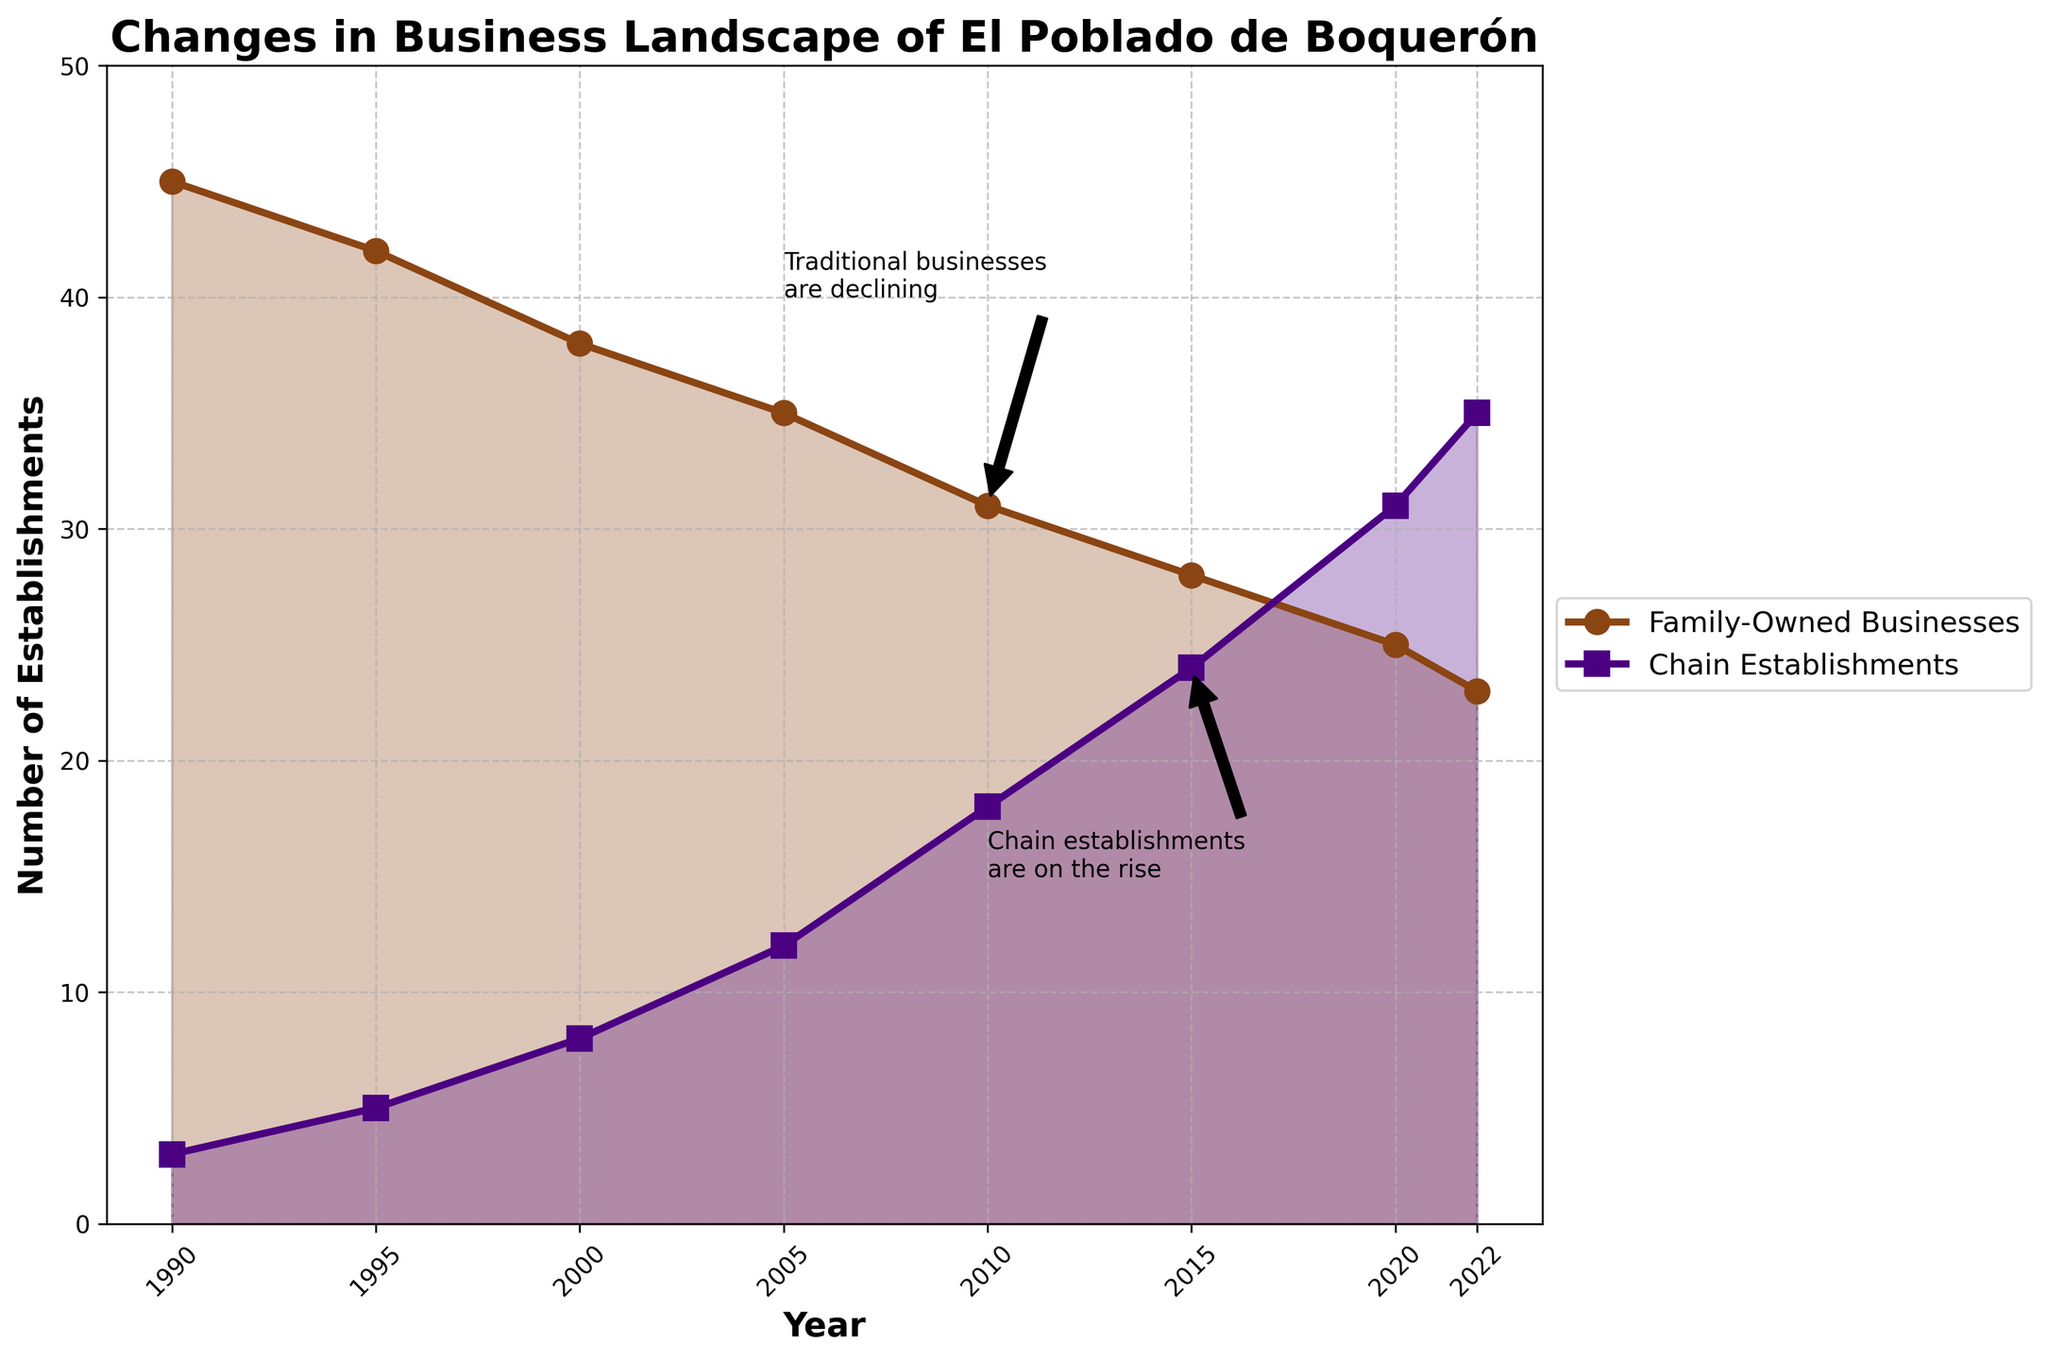What is the overall trend for family-owned businesses from 1990 to 2022? The number of family-owned businesses consistently decreases from 45 in 1990 to 23 in 2022.
Answer: Decreasing trend How many more chain establishments are there in 2022 compared to 1990? In 1990, there were 3 chain establishments, whereas in 2022 there are 35. The difference is 35 - 3.
Answer: 32 Which year had the highest increase in chain establishments compared to the previous period? Compare the increases for each period:
1990-1995: 5 - 3 = 2
1995-2000: 8 - 5 = 3
2000-2005: 12 - 8 = 4
2005-2010: 18 - 12 = 6
2010-2015: 24 - 18 = 6
2015-2020: 31 - 24 = 7
2020-2022: 35 - 31 = 4
The highest increase is in 2015-2020 with an increase of 7.
Answer: 2015-2020 What was the number of family-owned businesses and chain establishments in 2005, and which type was more prevalent? In 2005, there were 35 family-owned businesses and 12 chain establishments. Family-owned businesses were more prevalent.
Answer: Family-owned businesses In which year did chain establishments outnumber family-owned businesses? Chain establishments surpassed family-owned businesses when chain establishments reached 31 in 2020, compared to 25 family-owned businesses.
Answer: 2020 Is there a point in the graph where the two types of businesses have similar numbers, and if so, which year? The trends of the two types of businesses never intersect or get very close. However, in 2015, there were 28 family-owned businesses and 24 chain establishments, which is the closest they get.
Answer: 2015 What is the approximate percentage decrease in family-owned businesses from 1990 to 2022? Calculate the percentage decrease: ((45 - 23) / 45) * 100 = (22 / 45) * 100 ≈ 48.89%.
Answer: 48.89% Comparing the increase in chain establishments from 2000 to 2022, by how many times did the number of establishments increase? In 2000, there were 8 chain establishments, and in 2022, there are 35. The increase factor is 35 / 8 = 4.375.
Answer: 4.375 times What is highlighted by the annotation about traditional businesses around the year 2010? The annotation around the year 2010 highlights the declining trend of family-owned (traditional) businesses, shown by the arrow pointing to a decreasing number of 31.
Answer: Decline in traditional businesses From 1990 to 2022, what is the average rate of decrease in family-owned businesses per year? Calculate the total decrease: 45 - 23 = 22. Divide by the number of years: 2022 - 1990 = 32 years. The average rate of decrease per year is 22 / 32 ≈ 0.6875.
Answer: 0.6875 per year 